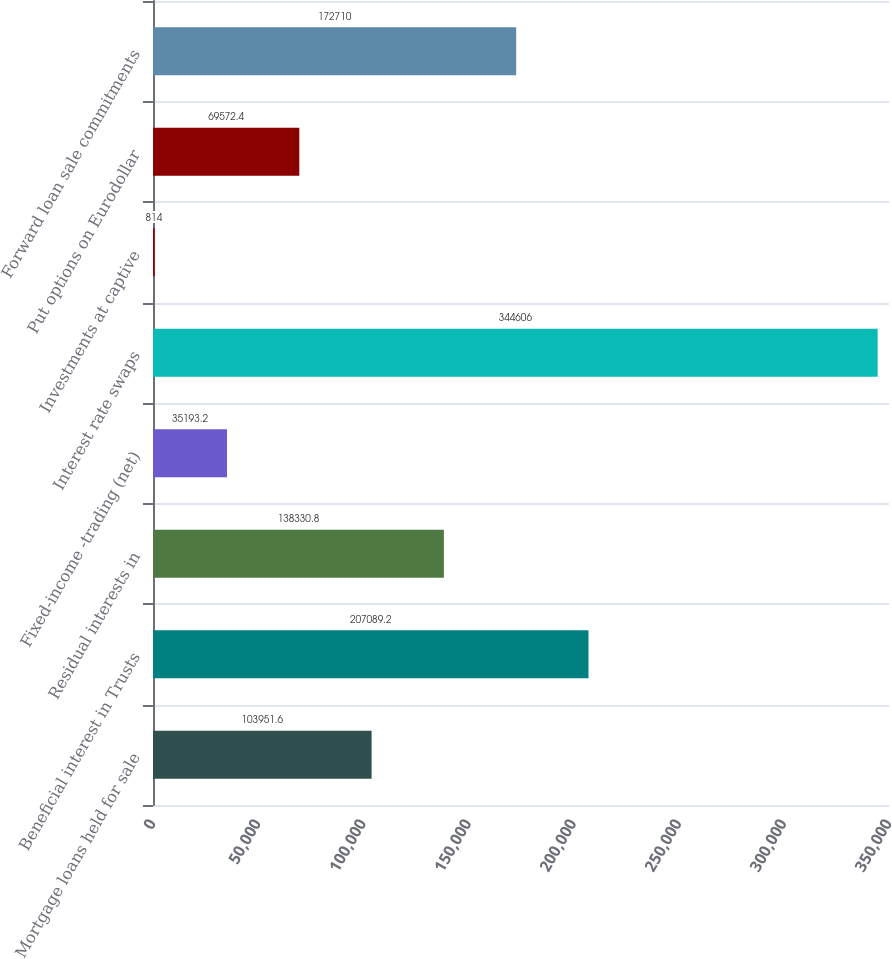<chart> <loc_0><loc_0><loc_500><loc_500><bar_chart><fcel>Mortgage loans held for sale<fcel>Beneficial interest in Trusts<fcel>Residual interests in<fcel>Fixed-income -trading (net)<fcel>Interest rate swaps<fcel>Investments at captive<fcel>Put options on Eurodollar<fcel>Forward loan sale commitments<nl><fcel>103952<fcel>207089<fcel>138331<fcel>35193.2<fcel>344606<fcel>814<fcel>69572.4<fcel>172710<nl></chart> 